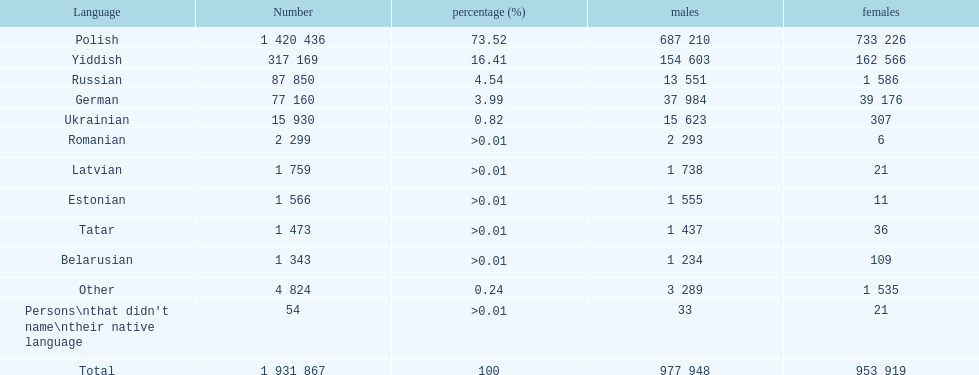What was the foremost language out of those with a percentage above Romanian. Parse the full table. {'header': ['Language', 'Number', 'percentage (%)', 'males', 'females'], 'rows': [['Polish', '1 420 436', '73.52', '687 210', '733 226'], ['Yiddish', '317 169', '16.41', '154 603', '162 566'], ['Russian', '87 850', '4.54', '13 551', '1 586'], ['German', '77 160', '3.99', '37 984', '39 176'], ['Ukrainian', '15 930', '0.82', '15 623', '307'], ['Romanian', '2 299', '>0.01', '2 293', '6'], ['Latvian', '1 759', '>0.01', '1 738', '21'], ['Estonian', '1 566', '>0.01', '1 555', '11'], ['Tatar', '1 473', '>0.01', '1 437', '36'], ['Belarusian', '1 343', '>0.01', '1 234', '109'], ['Other', '4 824', '0.24', '3 289', '1 535'], ["Persons\\nthat didn't name\\ntheir native language", '54', '>0.01', '33', '21'], ['Total', '1 931 867', '100', '977 948', '953 919']]} 